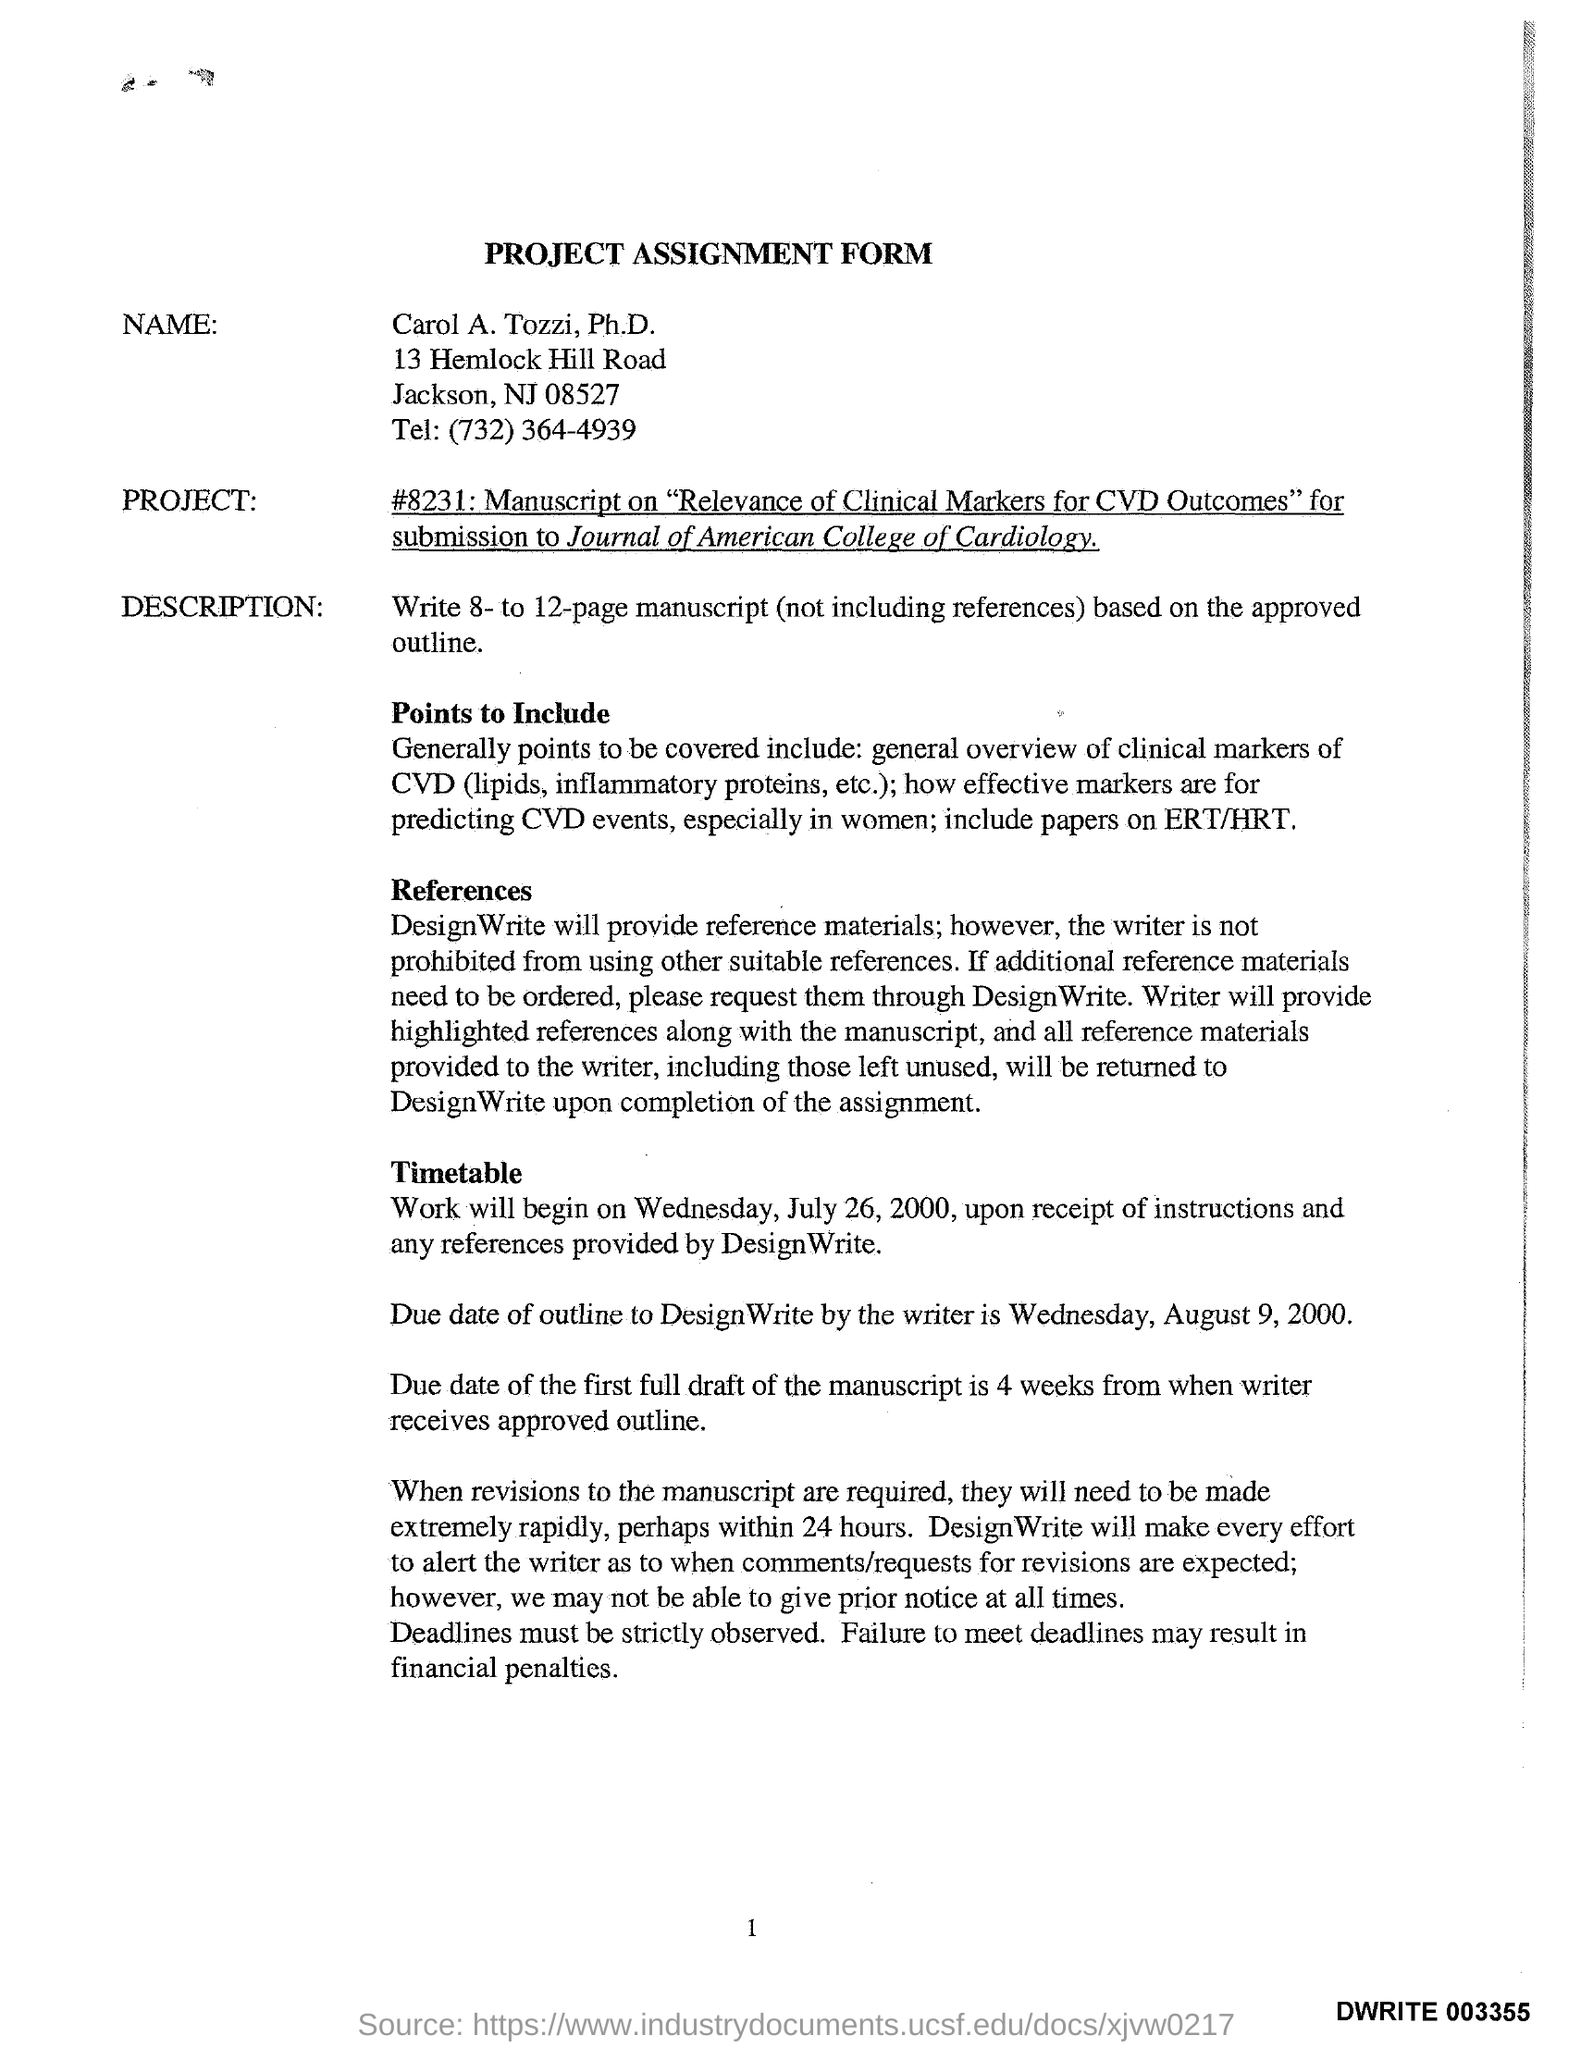What is the title of the Form?
Offer a very short reply. Project assignment form. When will the work begin?
Your answer should be compact. Wednesday, July 26, 2000. 